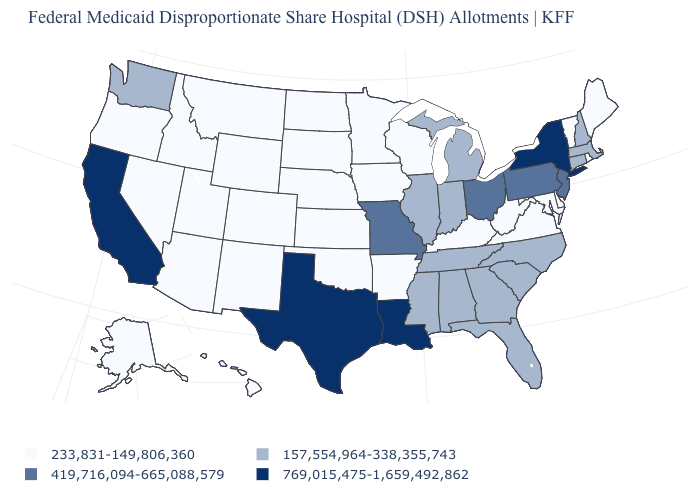What is the value of Pennsylvania?
Quick response, please. 419,716,094-665,088,579. How many symbols are there in the legend?
Be succinct. 4. What is the value of West Virginia?
Be succinct. 233,831-149,806,360. What is the value of Mississippi?
Quick response, please. 157,554,964-338,355,743. Which states have the lowest value in the USA?
Quick response, please. Alaska, Arizona, Arkansas, Colorado, Delaware, Hawaii, Idaho, Iowa, Kansas, Kentucky, Maine, Maryland, Minnesota, Montana, Nebraska, Nevada, New Mexico, North Dakota, Oklahoma, Oregon, Rhode Island, South Dakota, Utah, Vermont, Virginia, West Virginia, Wisconsin, Wyoming. Name the states that have a value in the range 769,015,475-1,659,492,862?
Concise answer only. California, Louisiana, New York, Texas. What is the highest value in states that border Mississippi?
Write a very short answer. 769,015,475-1,659,492,862. Among the states that border Tennessee , which have the highest value?
Answer briefly. Missouri. Which states have the lowest value in the MidWest?
Give a very brief answer. Iowa, Kansas, Minnesota, Nebraska, North Dakota, South Dakota, Wisconsin. Does South Carolina have the highest value in the South?
Keep it brief. No. Which states have the highest value in the USA?
Concise answer only. California, Louisiana, New York, Texas. What is the highest value in the South ?
Quick response, please. 769,015,475-1,659,492,862. Does the first symbol in the legend represent the smallest category?
Be succinct. Yes. What is the value of Wyoming?
Quick response, please. 233,831-149,806,360. Name the states that have a value in the range 419,716,094-665,088,579?
Quick response, please. Missouri, New Jersey, Ohio, Pennsylvania. 